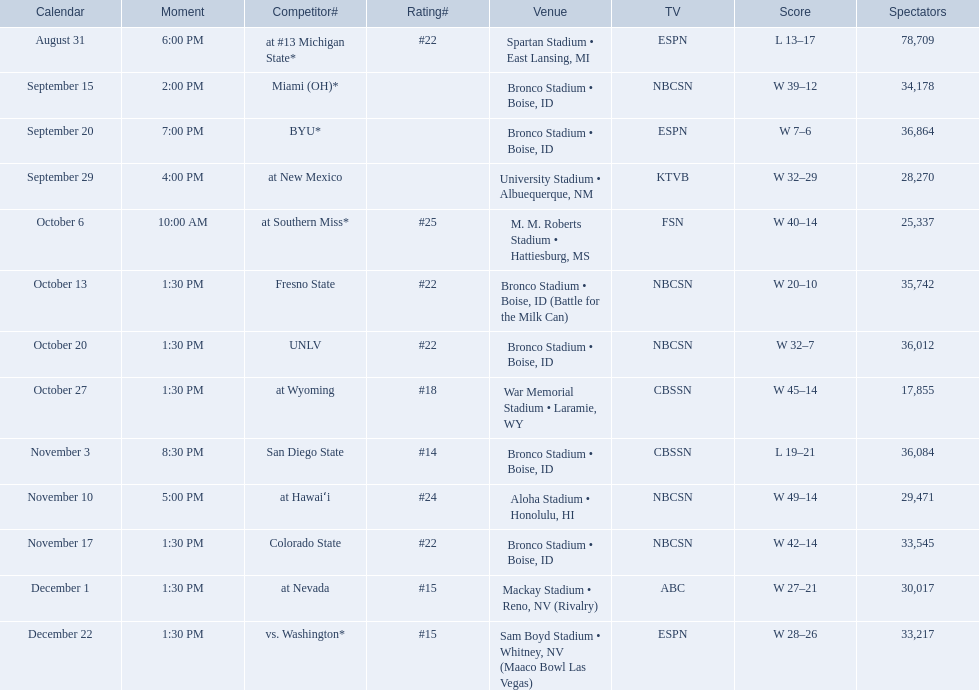Who were all the opponents for boise state? At #13 michigan state*, miami (oh)*, byu*, at new mexico, at southern miss*, fresno state, unlv, at wyoming, san diego state, at hawaiʻi, colorado state, at nevada, vs. washington*. Which opponents were ranked? At #13 michigan state*, #22, at southern miss*, #25, fresno state, #22, unlv, #22, at wyoming, #18, san diego state, #14. Which opponent had the highest rank? San Diego State. 